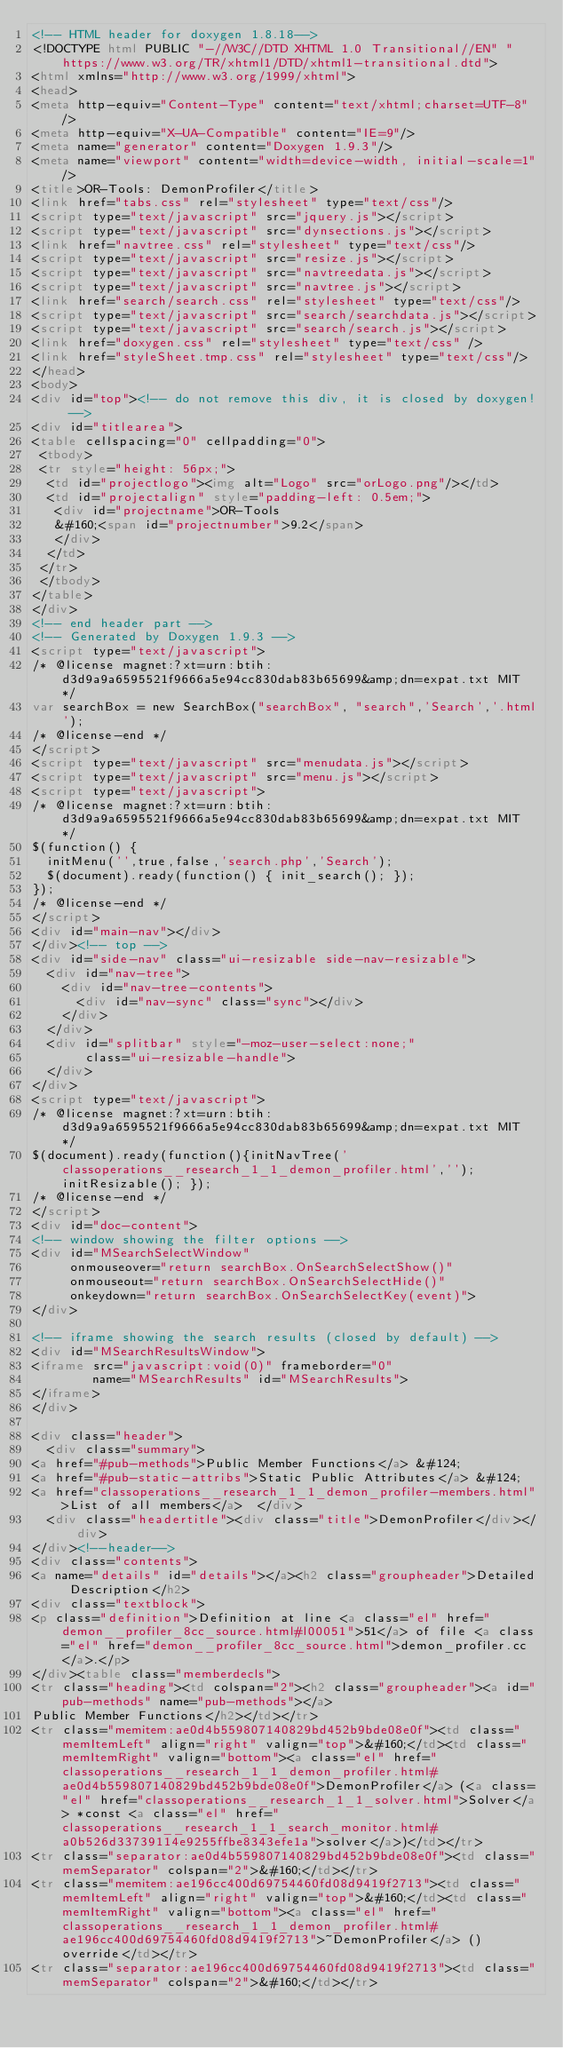<code> <loc_0><loc_0><loc_500><loc_500><_HTML_><!-- HTML header for doxygen 1.8.18-->
<!DOCTYPE html PUBLIC "-//W3C//DTD XHTML 1.0 Transitional//EN" "https://www.w3.org/TR/xhtml1/DTD/xhtml1-transitional.dtd">
<html xmlns="http://www.w3.org/1999/xhtml">
<head>
<meta http-equiv="Content-Type" content="text/xhtml;charset=UTF-8"/>
<meta http-equiv="X-UA-Compatible" content="IE=9"/>
<meta name="generator" content="Doxygen 1.9.3"/>
<meta name="viewport" content="width=device-width, initial-scale=1"/>
<title>OR-Tools: DemonProfiler</title>
<link href="tabs.css" rel="stylesheet" type="text/css"/>
<script type="text/javascript" src="jquery.js"></script>
<script type="text/javascript" src="dynsections.js"></script>
<link href="navtree.css" rel="stylesheet" type="text/css"/>
<script type="text/javascript" src="resize.js"></script>
<script type="text/javascript" src="navtreedata.js"></script>
<script type="text/javascript" src="navtree.js"></script>
<link href="search/search.css" rel="stylesheet" type="text/css"/>
<script type="text/javascript" src="search/searchdata.js"></script>
<script type="text/javascript" src="search/search.js"></script>
<link href="doxygen.css" rel="stylesheet" type="text/css" />
<link href="styleSheet.tmp.css" rel="stylesheet" type="text/css"/>
</head>
<body>
<div id="top"><!-- do not remove this div, it is closed by doxygen! -->
<div id="titlearea">
<table cellspacing="0" cellpadding="0">
 <tbody>
 <tr style="height: 56px;">
  <td id="projectlogo"><img alt="Logo" src="orLogo.png"/></td>
  <td id="projectalign" style="padding-left: 0.5em;">
   <div id="projectname">OR-Tools
   &#160;<span id="projectnumber">9.2</span>
   </div>
  </td>
 </tr>
 </tbody>
</table>
</div>
<!-- end header part -->
<!-- Generated by Doxygen 1.9.3 -->
<script type="text/javascript">
/* @license magnet:?xt=urn:btih:d3d9a9a6595521f9666a5e94cc830dab83b65699&amp;dn=expat.txt MIT */
var searchBox = new SearchBox("searchBox", "search",'Search','.html');
/* @license-end */
</script>
<script type="text/javascript" src="menudata.js"></script>
<script type="text/javascript" src="menu.js"></script>
<script type="text/javascript">
/* @license magnet:?xt=urn:btih:d3d9a9a6595521f9666a5e94cc830dab83b65699&amp;dn=expat.txt MIT */
$(function() {
  initMenu('',true,false,'search.php','Search');
  $(document).ready(function() { init_search(); });
});
/* @license-end */
</script>
<div id="main-nav"></div>
</div><!-- top -->
<div id="side-nav" class="ui-resizable side-nav-resizable">
  <div id="nav-tree">
    <div id="nav-tree-contents">
      <div id="nav-sync" class="sync"></div>
    </div>
  </div>
  <div id="splitbar" style="-moz-user-select:none;" 
       class="ui-resizable-handle">
  </div>
</div>
<script type="text/javascript">
/* @license magnet:?xt=urn:btih:d3d9a9a6595521f9666a5e94cc830dab83b65699&amp;dn=expat.txt MIT */
$(document).ready(function(){initNavTree('classoperations__research_1_1_demon_profiler.html',''); initResizable(); });
/* @license-end */
</script>
<div id="doc-content">
<!-- window showing the filter options -->
<div id="MSearchSelectWindow"
     onmouseover="return searchBox.OnSearchSelectShow()"
     onmouseout="return searchBox.OnSearchSelectHide()"
     onkeydown="return searchBox.OnSearchSelectKey(event)">
</div>

<!-- iframe showing the search results (closed by default) -->
<div id="MSearchResultsWindow">
<iframe src="javascript:void(0)" frameborder="0" 
        name="MSearchResults" id="MSearchResults">
</iframe>
</div>

<div class="header">
  <div class="summary">
<a href="#pub-methods">Public Member Functions</a> &#124;
<a href="#pub-static-attribs">Static Public Attributes</a> &#124;
<a href="classoperations__research_1_1_demon_profiler-members.html">List of all members</a>  </div>
  <div class="headertitle"><div class="title">DemonProfiler</div></div>
</div><!--header-->
<div class="contents">
<a name="details" id="details"></a><h2 class="groupheader">Detailed Description</h2>
<div class="textblock">
<p class="definition">Definition at line <a class="el" href="demon__profiler_8cc_source.html#l00051">51</a> of file <a class="el" href="demon__profiler_8cc_source.html">demon_profiler.cc</a>.</p>
</div><table class="memberdecls">
<tr class="heading"><td colspan="2"><h2 class="groupheader"><a id="pub-methods" name="pub-methods"></a>
Public Member Functions</h2></td></tr>
<tr class="memitem:ae0d4b559807140829bd452b9bde08e0f"><td class="memItemLeft" align="right" valign="top">&#160;</td><td class="memItemRight" valign="bottom"><a class="el" href="classoperations__research_1_1_demon_profiler.html#ae0d4b559807140829bd452b9bde08e0f">DemonProfiler</a> (<a class="el" href="classoperations__research_1_1_solver.html">Solver</a> *const <a class="el" href="classoperations__research_1_1_search_monitor.html#a0b526d33739114e9255ffbe8343efe1a">solver</a>)</td></tr>
<tr class="separator:ae0d4b559807140829bd452b9bde08e0f"><td class="memSeparator" colspan="2">&#160;</td></tr>
<tr class="memitem:ae196cc400d69754460fd08d9419f2713"><td class="memItemLeft" align="right" valign="top">&#160;</td><td class="memItemRight" valign="bottom"><a class="el" href="classoperations__research_1_1_demon_profiler.html#ae196cc400d69754460fd08d9419f2713">~DemonProfiler</a> () override</td></tr>
<tr class="separator:ae196cc400d69754460fd08d9419f2713"><td class="memSeparator" colspan="2">&#160;</td></tr></code> 